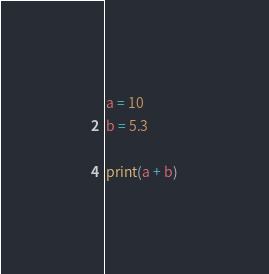<code> <loc_0><loc_0><loc_500><loc_500><_Python_>a = 10
b = 5.3

print(a + b)
</code> 